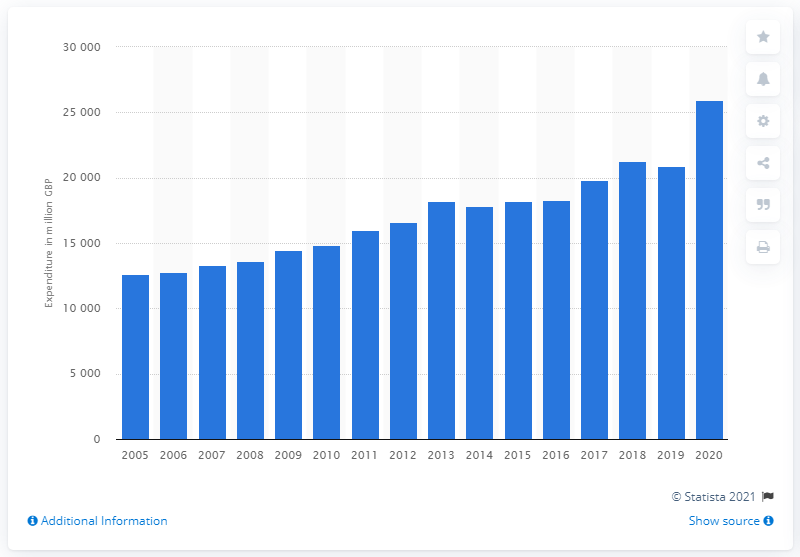What could be the reasons for the sharp increase in expenditure in 2020? The sharp increase in expenditure on alcoholic drinks in 2020 might be attributed to various factors, such as changes in purchasing behavior due to the COVID-19 pandemic, where consumers might have increased at-home consumption while bars and restaurants were closed, stockpiling, or a shift towards more premium products. 